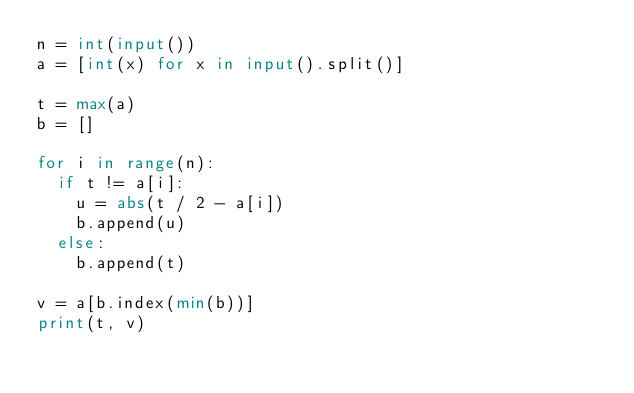<code> <loc_0><loc_0><loc_500><loc_500><_Python_>n = int(input())
a = [int(x) for x in input().split()]

t = max(a)
b = []

for i in range(n):
  if t != a[i]:
    u = abs(t / 2 - a[i])
    b.append(u)
  else:
    b.append(t)

v = a[b.index(min(b))]
print(t, v)
</code> 